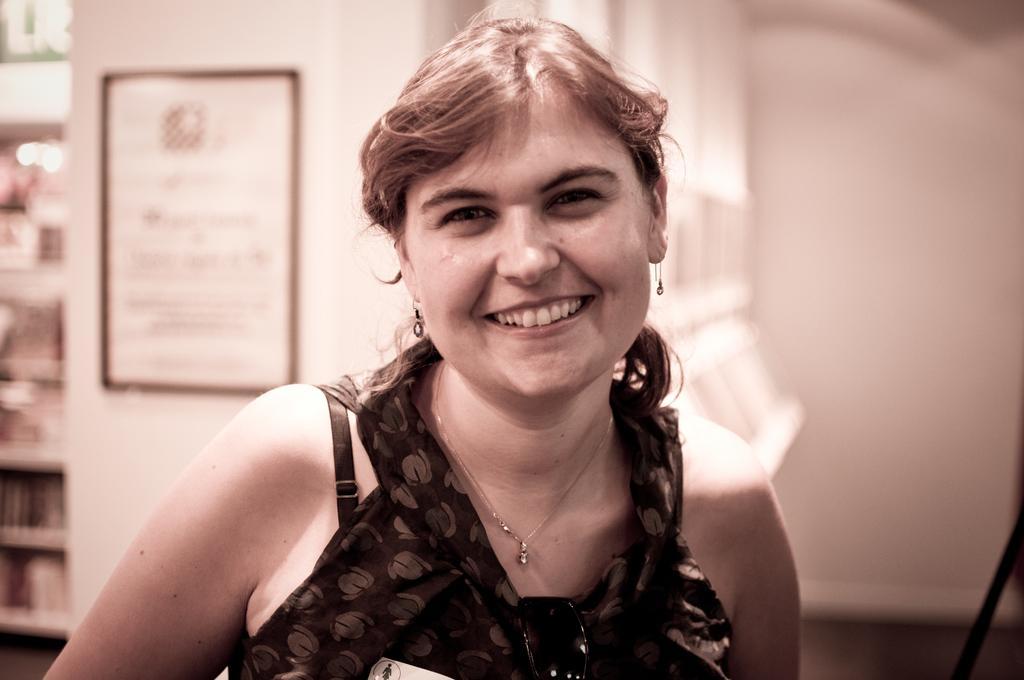Please provide a concise description of this image. In this image in the foreground there is one woman who is smiling, and in the background there is one photo frame on the wall. And on the left side there is a book rack, in that book rack there are some books and some lights. 